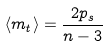Convert formula to latex. <formula><loc_0><loc_0><loc_500><loc_500>\langle m _ { t } \rangle = \frac { 2 p _ { s } } { n - 3 }</formula> 